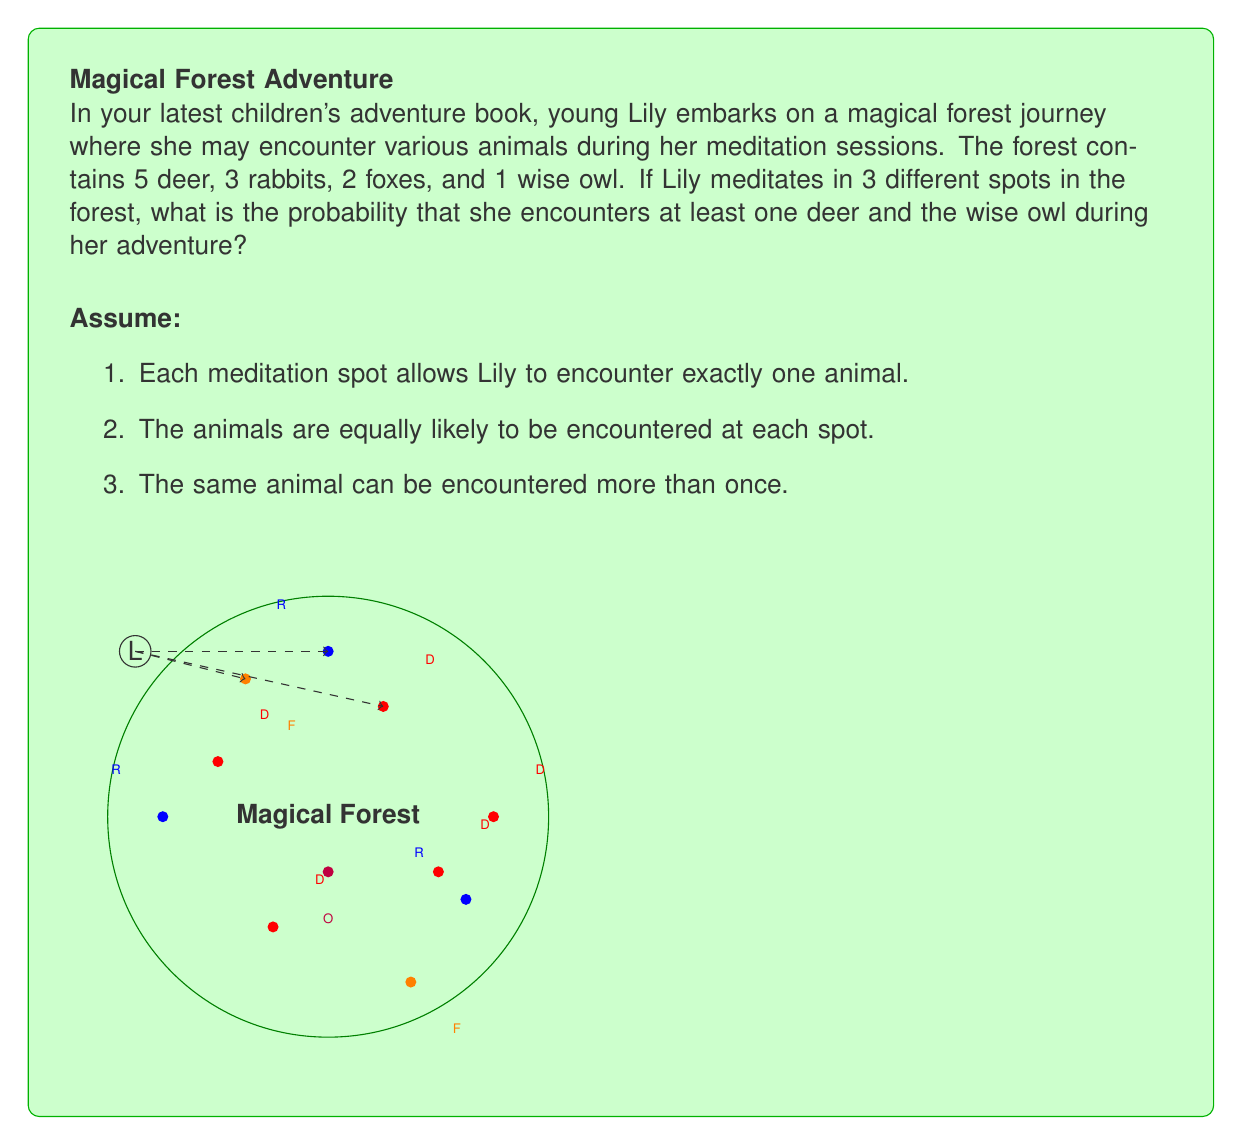Give your solution to this math problem. Let's approach this step-by-step:

1) First, we need to calculate the total number of animals:
   $5 + 3 + 2 + 1 = 11$ animals in total

2) The probability of encountering a deer in one meditation spot is:
   $P(\text{deer}) = \frac{5}{11}$

3) The probability of encountering the owl in one meditation spot is:
   $P(\text{owl}) = \frac{1}{11}$

4) Now, let's calculate the probability of not encountering a deer in all 3 spots:
   $P(\text{no deer}) = (\frac{6}{11})^3$

5) The probability of encountering at least one deer is:
   $P(\text{at least one deer}) = 1 - P(\text{no deer}) = 1 - (\frac{6}{11})^3$

6) The probability of not encountering the owl in all 3 spots:
   $P(\text{no owl}) = (\frac{10}{11})^3$

7) The probability of encountering the owl is:
   $P(\text{owl}) = 1 - P(\text{no owl}) = 1 - (\frac{10}{11})^3$

8) The probability of encountering at least one deer AND the owl is the product of these probabilities:

   $$P(\text{at least one deer and owl}) = [1 - (\frac{6}{11})^3] \times [1 - (\frac{10}{11})^3]$$

9) Let's calculate:
   $$= [1 - (\frac{216}{1331})] \times [1 - (\frac{1000}{1331})]$$
   $$= (\frac{1115}{1331}) \times (\frac{331}{1331})$$
   $$= \frac{369065}{1771561}$$
   $$\approx 0.2083 \text{ or about } 20.83\%$$
Answer: $\frac{369065}{1771561} \approx 0.2083$ 